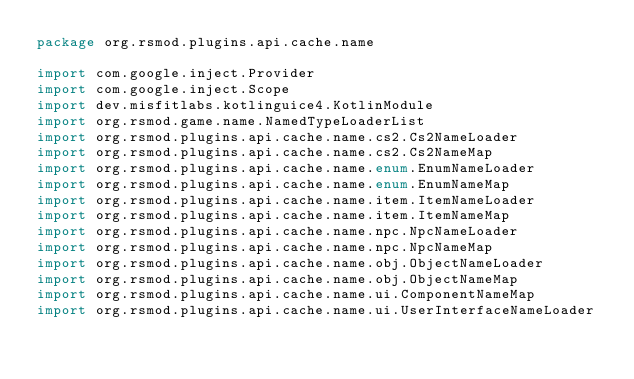Convert code to text. <code><loc_0><loc_0><loc_500><loc_500><_Kotlin_>package org.rsmod.plugins.api.cache.name

import com.google.inject.Provider
import com.google.inject.Scope
import dev.misfitlabs.kotlinguice4.KotlinModule
import org.rsmod.game.name.NamedTypeLoaderList
import org.rsmod.plugins.api.cache.name.cs2.Cs2NameLoader
import org.rsmod.plugins.api.cache.name.cs2.Cs2NameMap
import org.rsmod.plugins.api.cache.name.enum.EnumNameLoader
import org.rsmod.plugins.api.cache.name.enum.EnumNameMap
import org.rsmod.plugins.api.cache.name.item.ItemNameLoader
import org.rsmod.plugins.api.cache.name.item.ItemNameMap
import org.rsmod.plugins.api.cache.name.npc.NpcNameLoader
import org.rsmod.plugins.api.cache.name.npc.NpcNameMap
import org.rsmod.plugins.api.cache.name.obj.ObjectNameLoader
import org.rsmod.plugins.api.cache.name.obj.ObjectNameMap
import org.rsmod.plugins.api.cache.name.ui.ComponentNameMap
import org.rsmod.plugins.api.cache.name.ui.UserInterfaceNameLoader</code> 